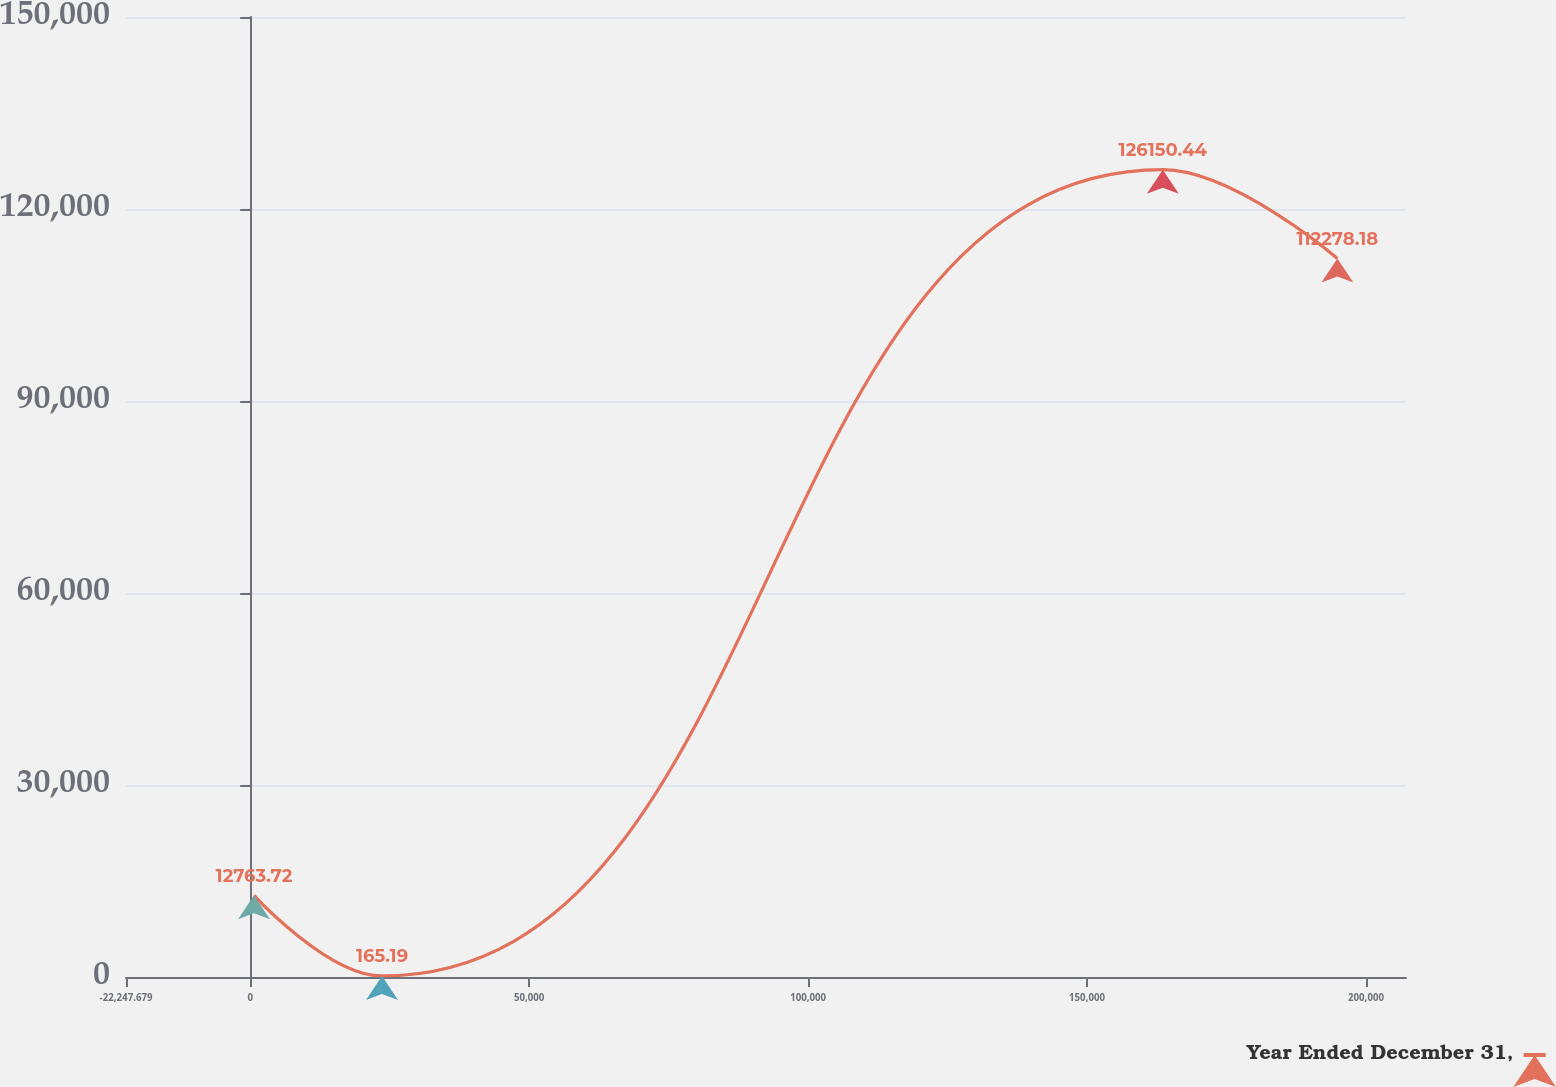Convert chart to OTSL. <chart><loc_0><loc_0><loc_500><loc_500><line_chart><ecel><fcel>Year Ended December 31,<nl><fcel>692.82<fcel>12763.7<nl><fcel>23633.3<fcel>165.19<nl><fcel>163571<fcel>126150<nl><fcel>194853<fcel>112278<nl><fcel>230098<fcel>99679.7<nl></chart> 